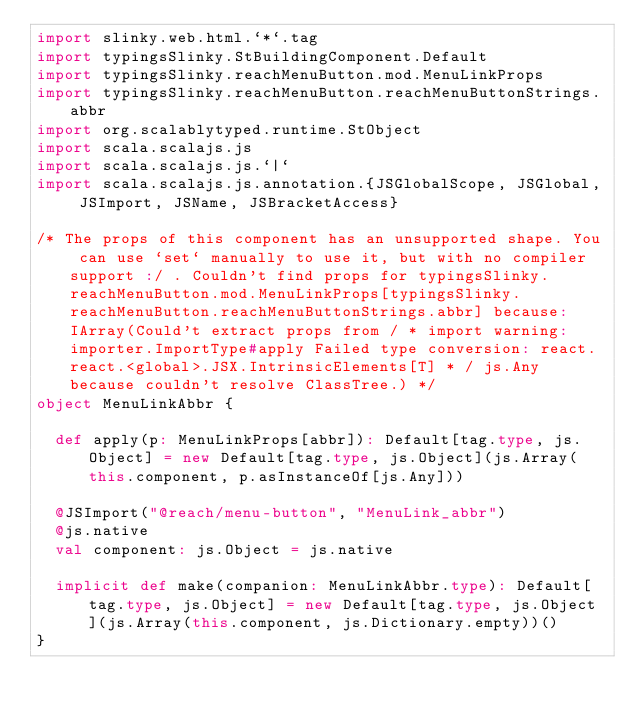Convert code to text. <code><loc_0><loc_0><loc_500><loc_500><_Scala_>import slinky.web.html.`*`.tag
import typingsSlinky.StBuildingComponent.Default
import typingsSlinky.reachMenuButton.mod.MenuLinkProps
import typingsSlinky.reachMenuButton.reachMenuButtonStrings.abbr
import org.scalablytyped.runtime.StObject
import scala.scalajs.js
import scala.scalajs.js.`|`
import scala.scalajs.js.annotation.{JSGlobalScope, JSGlobal, JSImport, JSName, JSBracketAccess}

/* The props of this component has an unsupported shape. You can use `set` manually to use it, but with no compiler support :/ . Couldn't find props for typingsSlinky.reachMenuButton.mod.MenuLinkProps[typingsSlinky.reachMenuButton.reachMenuButtonStrings.abbr] because: IArray(Could't extract props from / * import warning: importer.ImportType#apply Failed type conversion: react.react.<global>.JSX.IntrinsicElements[T] * / js.Any because couldn't resolve ClassTree.) */
object MenuLinkAbbr {
  
  def apply(p: MenuLinkProps[abbr]): Default[tag.type, js.Object] = new Default[tag.type, js.Object](js.Array(this.component, p.asInstanceOf[js.Any]))
  
  @JSImport("@reach/menu-button", "MenuLink_abbr")
  @js.native
  val component: js.Object = js.native
  
  implicit def make(companion: MenuLinkAbbr.type): Default[tag.type, js.Object] = new Default[tag.type, js.Object](js.Array(this.component, js.Dictionary.empty))()
}
</code> 